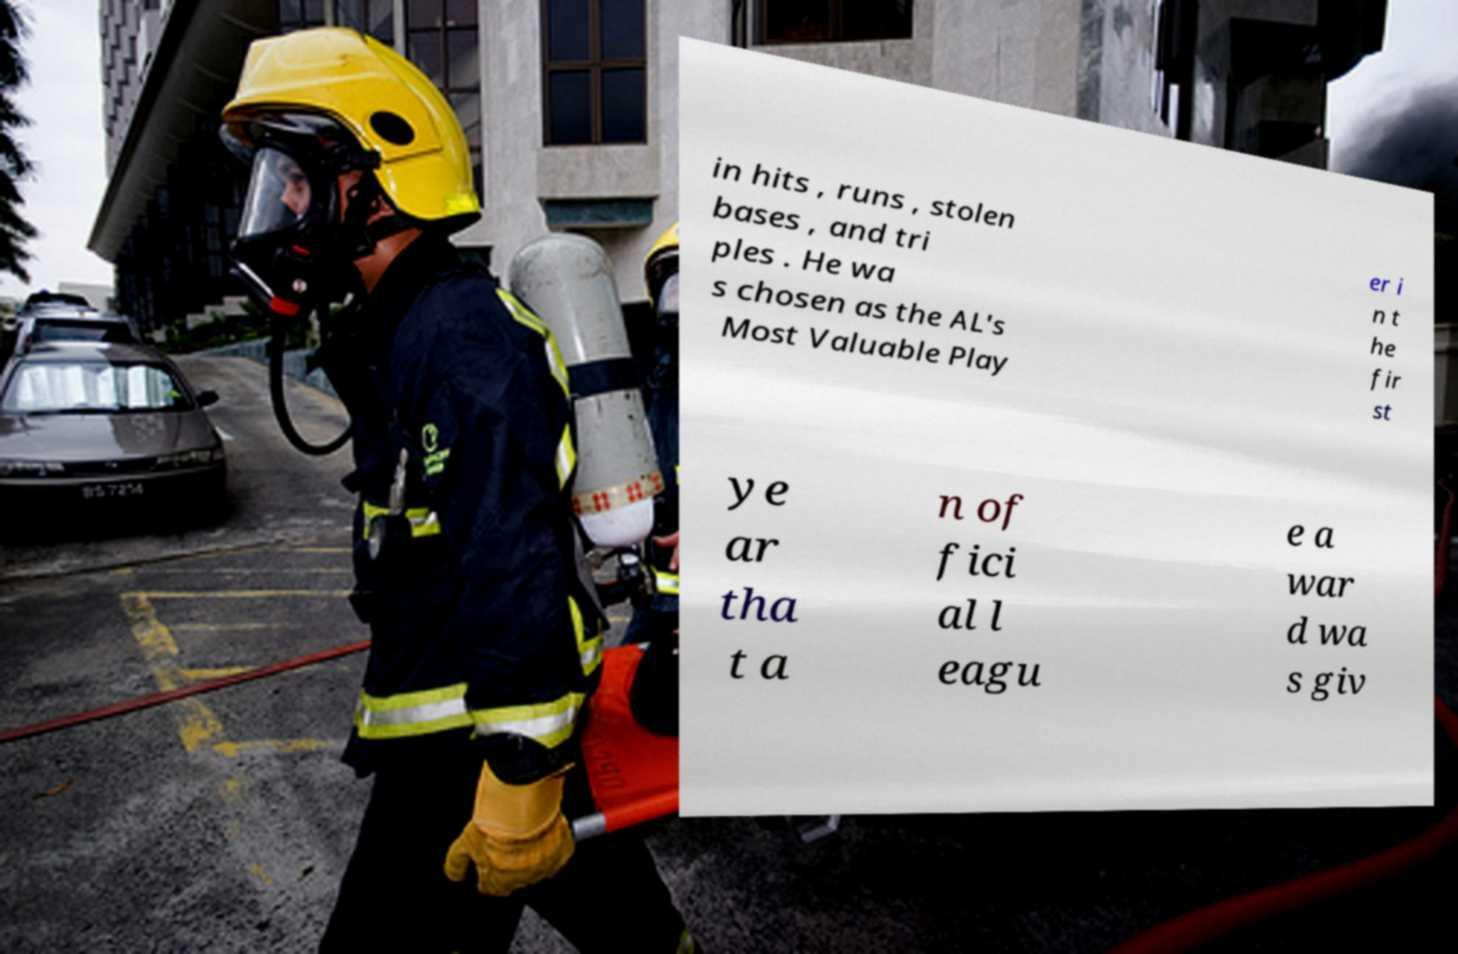I need the written content from this picture converted into text. Can you do that? in hits , runs , stolen bases , and tri ples . He wa s chosen as the AL's Most Valuable Play er i n t he fir st ye ar tha t a n of fici al l eagu e a war d wa s giv 